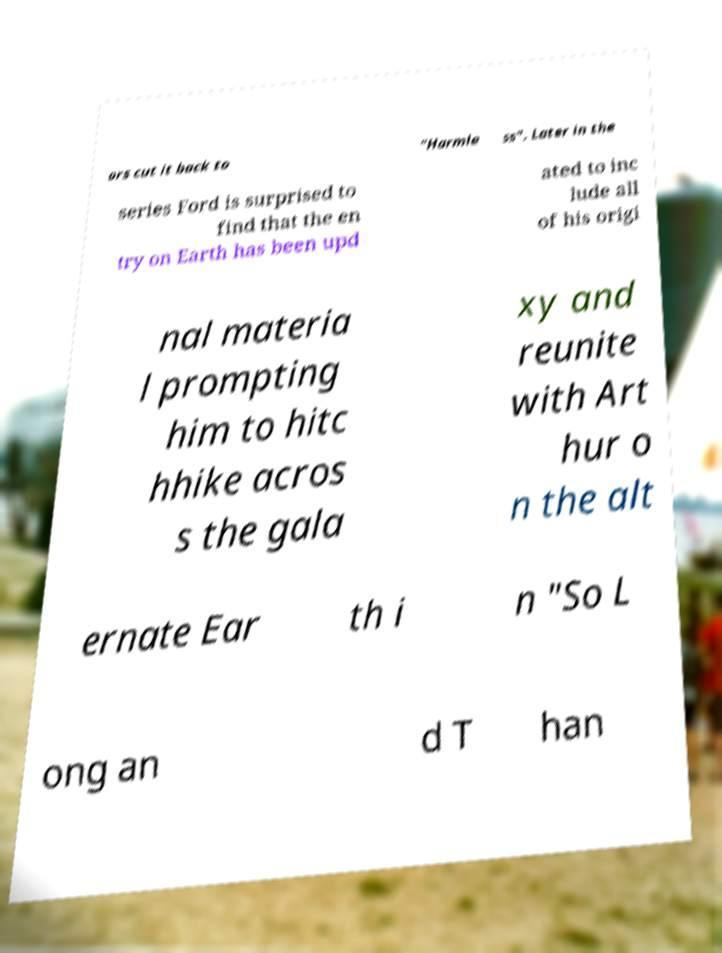Please read and relay the text visible in this image. What does it say? ors cut it back to "Harmle ss". Later in the series Ford is surprised to find that the en try on Earth has been upd ated to inc lude all of his origi nal materia l prompting him to hitc hhike acros s the gala xy and reunite with Art hur o n the alt ernate Ear th i n "So L ong an d T han 